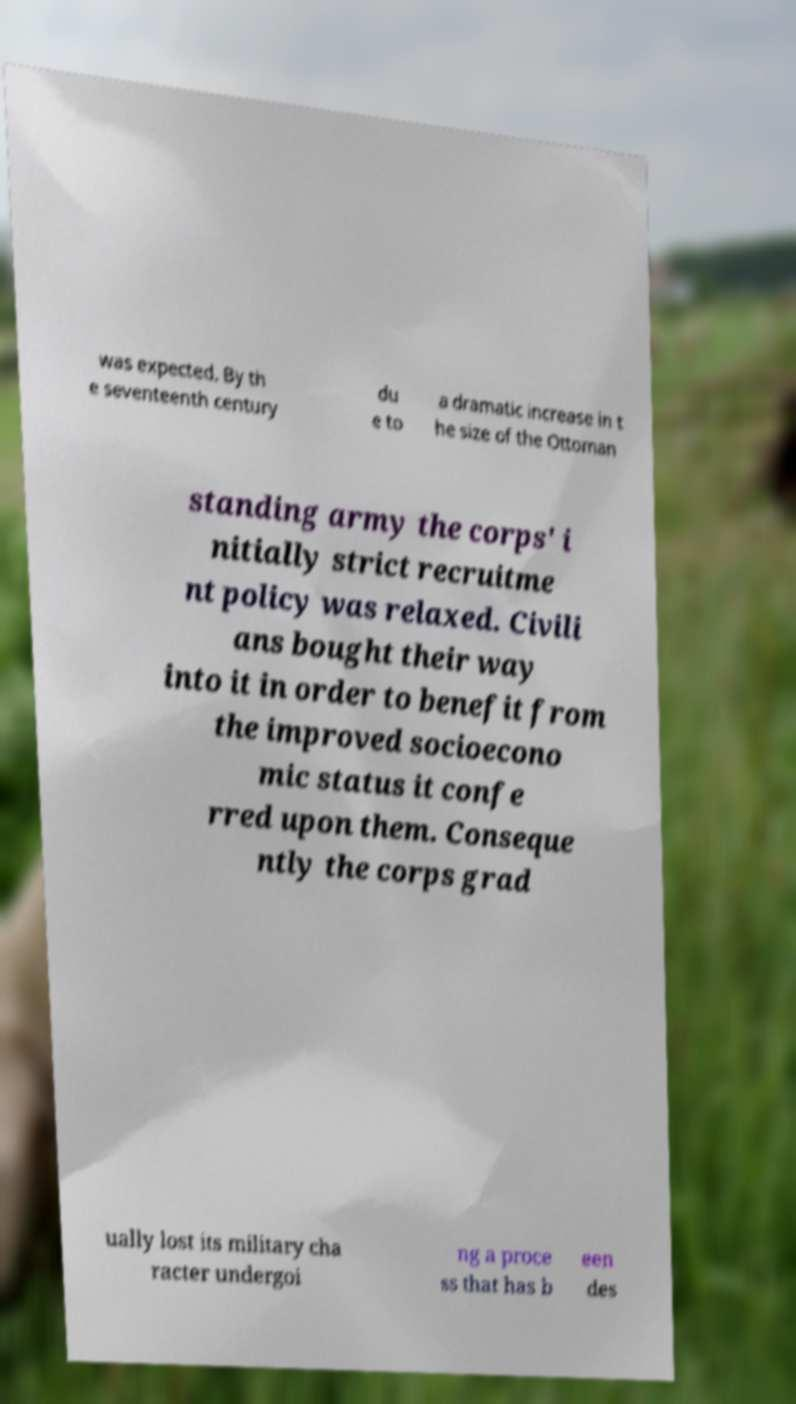Can you accurately transcribe the text from the provided image for me? was expected. By th e seventeenth century du e to a dramatic increase in t he size of the Ottoman standing army the corps' i nitially strict recruitme nt policy was relaxed. Civili ans bought their way into it in order to benefit from the improved socioecono mic status it confe rred upon them. Conseque ntly the corps grad ually lost its military cha racter undergoi ng a proce ss that has b een des 